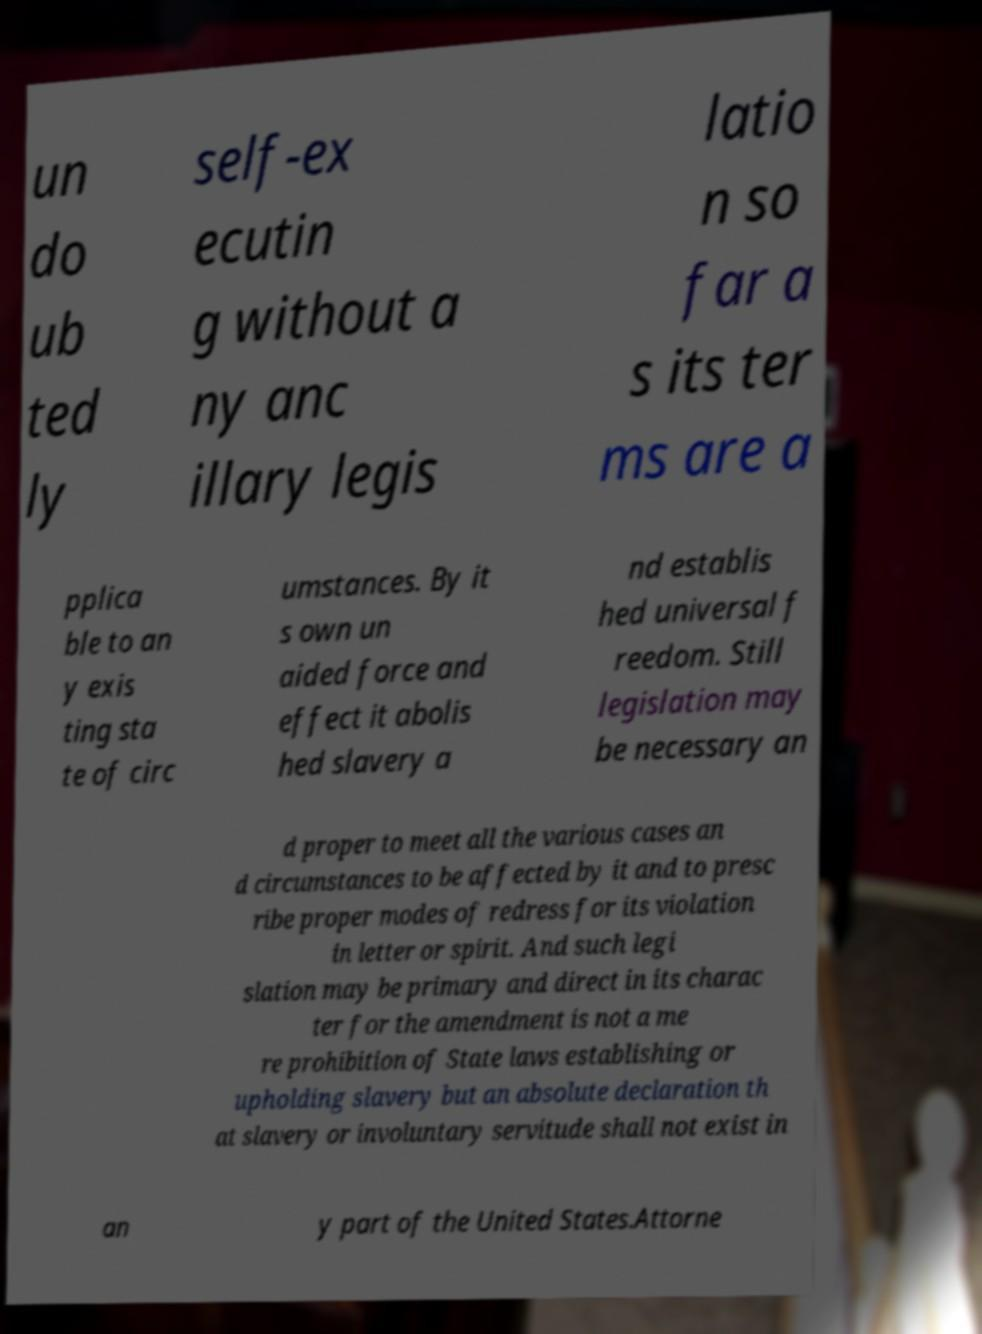Can you accurately transcribe the text from the provided image for me? un do ub ted ly self-ex ecutin g without a ny anc illary legis latio n so far a s its ter ms are a pplica ble to an y exis ting sta te of circ umstances. By it s own un aided force and effect it abolis hed slavery a nd establis hed universal f reedom. Still legislation may be necessary an d proper to meet all the various cases an d circumstances to be affected by it and to presc ribe proper modes of redress for its violation in letter or spirit. And such legi slation may be primary and direct in its charac ter for the amendment is not a me re prohibition of State laws establishing or upholding slavery but an absolute declaration th at slavery or involuntary servitude shall not exist in an y part of the United States.Attorne 